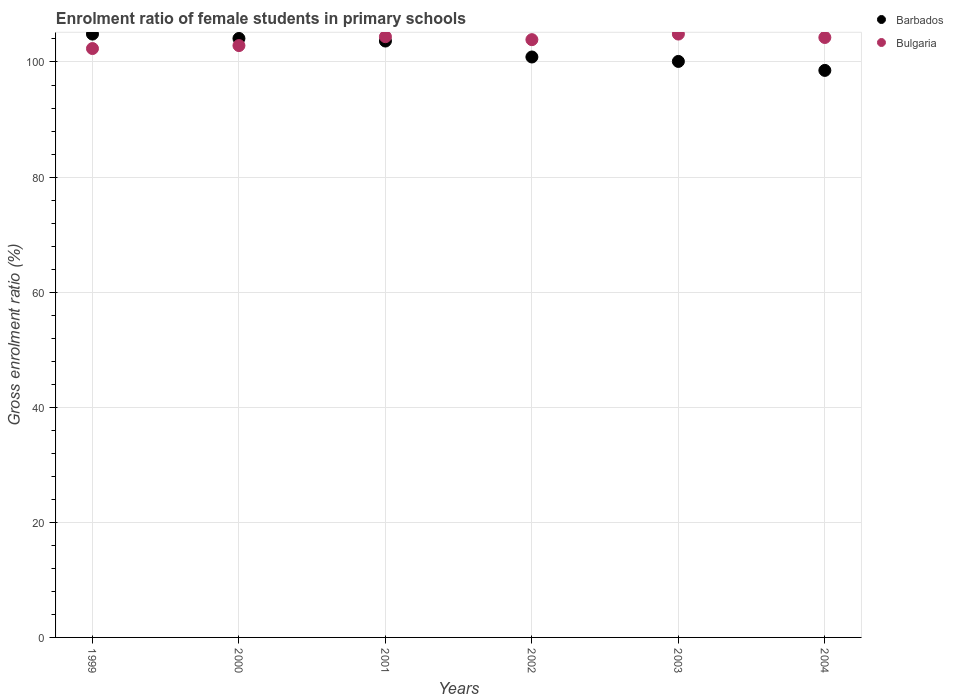How many different coloured dotlines are there?
Provide a short and direct response. 2. What is the enrolment ratio of female students in primary schools in Barbados in 2002?
Give a very brief answer. 100.87. Across all years, what is the maximum enrolment ratio of female students in primary schools in Bulgaria?
Make the answer very short. 104.85. Across all years, what is the minimum enrolment ratio of female students in primary schools in Barbados?
Offer a terse response. 98.54. In which year was the enrolment ratio of female students in primary schools in Bulgaria maximum?
Offer a very short reply. 2003. In which year was the enrolment ratio of female students in primary schools in Barbados minimum?
Provide a succinct answer. 2004. What is the total enrolment ratio of female students in primary schools in Bulgaria in the graph?
Make the answer very short. 622.57. What is the difference between the enrolment ratio of female students in primary schools in Barbados in 1999 and that in 2002?
Your answer should be compact. 3.98. What is the difference between the enrolment ratio of female students in primary schools in Bulgaria in 2004 and the enrolment ratio of female students in primary schools in Barbados in 2002?
Offer a terse response. 3.39. What is the average enrolment ratio of female students in primary schools in Barbados per year?
Give a very brief answer. 102.01. In the year 2001, what is the difference between the enrolment ratio of female students in primary schools in Bulgaria and enrolment ratio of female students in primary schools in Barbados?
Make the answer very short. 0.75. What is the ratio of the enrolment ratio of female students in primary schools in Bulgaria in 2002 to that in 2003?
Give a very brief answer. 0.99. Is the difference between the enrolment ratio of female students in primary schools in Bulgaria in 2001 and 2003 greater than the difference between the enrolment ratio of female students in primary schools in Barbados in 2001 and 2003?
Ensure brevity in your answer.  No. What is the difference between the highest and the second highest enrolment ratio of female students in primary schools in Barbados?
Give a very brief answer. 0.76. What is the difference between the highest and the lowest enrolment ratio of female students in primary schools in Barbados?
Provide a short and direct response. 6.31. Is the enrolment ratio of female students in primary schools in Barbados strictly less than the enrolment ratio of female students in primary schools in Bulgaria over the years?
Your answer should be very brief. No. How many dotlines are there?
Give a very brief answer. 2. What is the difference between two consecutive major ticks on the Y-axis?
Provide a short and direct response. 20. Are the values on the major ticks of Y-axis written in scientific E-notation?
Offer a terse response. No. Does the graph contain any zero values?
Make the answer very short. No. Does the graph contain grids?
Give a very brief answer. Yes. Where does the legend appear in the graph?
Provide a succinct answer. Top right. What is the title of the graph?
Offer a very short reply. Enrolment ratio of female students in primary schools. What is the label or title of the X-axis?
Keep it short and to the point. Years. What is the Gross enrolment ratio (%) of Barbados in 1999?
Your response must be concise. 104.85. What is the Gross enrolment ratio (%) in Bulgaria in 1999?
Your answer should be very brief. 102.34. What is the Gross enrolment ratio (%) of Barbados in 2000?
Make the answer very short. 104.09. What is the Gross enrolment ratio (%) of Bulgaria in 2000?
Give a very brief answer. 102.85. What is the Gross enrolment ratio (%) in Barbados in 2001?
Give a very brief answer. 103.64. What is the Gross enrolment ratio (%) in Bulgaria in 2001?
Ensure brevity in your answer.  104.39. What is the Gross enrolment ratio (%) in Barbados in 2002?
Ensure brevity in your answer.  100.87. What is the Gross enrolment ratio (%) of Bulgaria in 2002?
Your answer should be very brief. 103.88. What is the Gross enrolment ratio (%) of Barbados in 2003?
Your response must be concise. 100.1. What is the Gross enrolment ratio (%) in Bulgaria in 2003?
Give a very brief answer. 104.85. What is the Gross enrolment ratio (%) in Barbados in 2004?
Offer a terse response. 98.54. What is the Gross enrolment ratio (%) of Bulgaria in 2004?
Offer a terse response. 104.26. Across all years, what is the maximum Gross enrolment ratio (%) of Barbados?
Ensure brevity in your answer.  104.85. Across all years, what is the maximum Gross enrolment ratio (%) in Bulgaria?
Your answer should be compact. 104.85. Across all years, what is the minimum Gross enrolment ratio (%) in Barbados?
Offer a terse response. 98.54. Across all years, what is the minimum Gross enrolment ratio (%) of Bulgaria?
Give a very brief answer. 102.34. What is the total Gross enrolment ratio (%) of Barbados in the graph?
Provide a short and direct response. 612.08. What is the total Gross enrolment ratio (%) of Bulgaria in the graph?
Make the answer very short. 622.57. What is the difference between the Gross enrolment ratio (%) in Barbados in 1999 and that in 2000?
Your answer should be very brief. 0.76. What is the difference between the Gross enrolment ratio (%) in Bulgaria in 1999 and that in 2000?
Offer a terse response. -0.52. What is the difference between the Gross enrolment ratio (%) in Barbados in 1999 and that in 2001?
Keep it short and to the point. 1.21. What is the difference between the Gross enrolment ratio (%) of Bulgaria in 1999 and that in 2001?
Provide a short and direct response. -2.06. What is the difference between the Gross enrolment ratio (%) of Barbados in 1999 and that in 2002?
Your answer should be compact. 3.98. What is the difference between the Gross enrolment ratio (%) in Bulgaria in 1999 and that in 2002?
Keep it short and to the point. -1.54. What is the difference between the Gross enrolment ratio (%) in Barbados in 1999 and that in 2003?
Provide a succinct answer. 4.75. What is the difference between the Gross enrolment ratio (%) in Bulgaria in 1999 and that in 2003?
Make the answer very short. -2.52. What is the difference between the Gross enrolment ratio (%) in Barbados in 1999 and that in 2004?
Make the answer very short. 6.31. What is the difference between the Gross enrolment ratio (%) of Bulgaria in 1999 and that in 2004?
Offer a terse response. -1.92. What is the difference between the Gross enrolment ratio (%) of Barbados in 2000 and that in 2001?
Ensure brevity in your answer.  0.45. What is the difference between the Gross enrolment ratio (%) of Bulgaria in 2000 and that in 2001?
Give a very brief answer. -1.54. What is the difference between the Gross enrolment ratio (%) of Barbados in 2000 and that in 2002?
Offer a very short reply. 3.22. What is the difference between the Gross enrolment ratio (%) in Bulgaria in 2000 and that in 2002?
Your response must be concise. -1.03. What is the difference between the Gross enrolment ratio (%) of Barbados in 2000 and that in 2003?
Your response must be concise. 3.99. What is the difference between the Gross enrolment ratio (%) in Bulgaria in 2000 and that in 2003?
Your answer should be compact. -2. What is the difference between the Gross enrolment ratio (%) of Barbados in 2000 and that in 2004?
Your answer should be very brief. 5.55. What is the difference between the Gross enrolment ratio (%) in Bulgaria in 2000 and that in 2004?
Ensure brevity in your answer.  -1.4. What is the difference between the Gross enrolment ratio (%) of Barbados in 2001 and that in 2002?
Provide a succinct answer. 2.77. What is the difference between the Gross enrolment ratio (%) of Bulgaria in 2001 and that in 2002?
Provide a short and direct response. 0.52. What is the difference between the Gross enrolment ratio (%) of Barbados in 2001 and that in 2003?
Provide a succinct answer. 3.54. What is the difference between the Gross enrolment ratio (%) in Bulgaria in 2001 and that in 2003?
Your answer should be very brief. -0.46. What is the difference between the Gross enrolment ratio (%) in Barbados in 2001 and that in 2004?
Keep it short and to the point. 5.1. What is the difference between the Gross enrolment ratio (%) of Bulgaria in 2001 and that in 2004?
Ensure brevity in your answer.  0.14. What is the difference between the Gross enrolment ratio (%) in Barbados in 2002 and that in 2003?
Give a very brief answer. 0.77. What is the difference between the Gross enrolment ratio (%) of Bulgaria in 2002 and that in 2003?
Your answer should be very brief. -0.97. What is the difference between the Gross enrolment ratio (%) in Barbados in 2002 and that in 2004?
Your answer should be very brief. 2.33. What is the difference between the Gross enrolment ratio (%) of Bulgaria in 2002 and that in 2004?
Provide a succinct answer. -0.38. What is the difference between the Gross enrolment ratio (%) of Barbados in 2003 and that in 2004?
Offer a very short reply. 1.56. What is the difference between the Gross enrolment ratio (%) in Bulgaria in 2003 and that in 2004?
Provide a succinct answer. 0.6. What is the difference between the Gross enrolment ratio (%) in Barbados in 1999 and the Gross enrolment ratio (%) in Bulgaria in 2000?
Keep it short and to the point. 2. What is the difference between the Gross enrolment ratio (%) of Barbados in 1999 and the Gross enrolment ratio (%) of Bulgaria in 2001?
Your response must be concise. 0.45. What is the difference between the Gross enrolment ratio (%) in Barbados in 1999 and the Gross enrolment ratio (%) in Bulgaria in 2002?
Provide a short and direct response. 0.97. What is the difference between the Gross enrolment ratio (%) of Barbados in 1999 and the Gross enrolment ratio (%) of Bulgaria in 2003?
Make the answer very short. -0. What is the difference between the Gross enrolment ratio (%) in Barbados in 1999 and the Gross enrolment ratio (%) in Bulgaria in 2004?
Provide a succinct answer. 0.59. What is the difference between the Gross enrolment ratio (%) of Barbados in 2000 and the Gross enrolment ratio (%) of Bulgaria in 2001?
Keep it short and to the point. -0.31. What is the difference between the Gross enrolment ratio (%) of Barbados in 2000 and the Gross enrolment ratio (%) of Bulgaria in 2002?
Provide a short and direct response. 0.21. What is the difference between the Gross enrolment ratio (%) in Barbados in 2000 and the Gross enrolment ratio (%) in Bulgaria in 2003?
Offer a terse response. -0.76. What is the difference between the Gross enrolment ratio (%) in Barbados in 2000 and the Gross enrolment ratio (%) in Bulgaria in 2004?
Provide a short and direct response. -0.17. What is the difference between the Gross enrolment ratio (%) in Barbados in 2001 and the Gross enrolment ratio (%) in Bulgaria in 2002?
Make the answer very short. -0.24. What is the difference between the Gross enrolment ratio (%) of Barbados in 2001 and the Gross enrolment ratio (%) of Bulgaria in 2003?
Your answer should be compact. -1.21. What is the difference between the Gross enrolment ratio (%) of Barbados in 2001 and the Gross enrolment ratio (%) of Bulgaria in 2004?
Give a very brief answer. -0.62. What is the difference between the Gross enrolment ratio (%) of Barbados in 2002 and the Gross enrolment ratio (%) of Bulgaria in 2003?
Offer a very short reply. -3.98. What is the difference between the Gross enrolment ratio (%) in Barbados in 2002 and the Gross enrolment ratio (%) in Bulgaria in 2004?
Provide a short and direct response. -3.39. What is the difference between the Gross enrolment ratio (%) of Barbados in 2003 and the Gross enrolment ratio (%) of Bulgaria in 2004?
Offer a terse response. -4.16. What is the average Gross enrolment ratio (%) of Barbados per year?
Offer a very short reply. 102.01. What is the average Gross enrolment ratio (%) of Bulgaria per year?
Keep it short and to the point. 103.76. In the year 1999, what is the difference between the Gross enrolment ratio (%) in Barbados and Gross enrolment ratio (%) in Bulgaria?
Provide a succinct answer. 2.51. In the year 2000, what is the difference between the Gross enrolment ratio (%) of Barbados and Gross enrolment ratio (%) of Bulgaria?
Offer a very short reply. 1.24. In the year 2001, what is the difference between the Gross enrolment ratio (%) of Barbados and Gross enrolment ratio (%) of Bulgaria?
Your response must be concise. -0.75. In the year 2002, what is the difference between the Gross enrolment ratio (%) of Barbados and Gross enrolment ratio (%) of Bulgaria?
Your response must be concise. -3.01. In the year 2003, what is the difference between the Gross enrolment ratio (%) of Barbados and Gross enrolment ratio (%) of Bulgaria?
Provide a succinct answer. -4.75. In the year 2004, what is the difference between the Gross enrolment ratio (%) of Barbados and Gross enrolment ratio (%) of Bulgaria?
Ensure brevity in your answer.  -5.72. What is the ratio of the Gross enrolment ratio (%) in Barbados in 1999 to that in 2000?
Offer a terse response. 1.01. What is the ratio of the Gross enrolment ratio (%) of Bulgaria in 1999 to that in 2000?
Give a very brief answer. 0.99. What is the ratio of the Gross enrolment ratio (%) of Barbados in 1999 to that in 2001?
Offer a terse response. 1.01. What is the ratio of the Gross enrolment ratio (%) of Bulgaria in 1999 to that in 2001?
Your response must be concise. 0.98. What is the ratio of the Gross enrolment ratio (%) in Barbados in 1999 to that in 2002?
Give a very brief answer. 1.04. What is the ratio of the Gross enrolment ratio (%) in Bulgaria in 1999 to that in 2002?
Your response must be concise. 0.99. What is the ratio of the Gross enrolment ratio (%) in Barbados in 1999 to that in 2003?
Your response must be concise. 1.05. What is the ratio of the Gross enrolment ratio (%) of Barbados in 1999 to that in 2004?
Your response must be concise. 1.06. What is the ratio of the Gross enrolment ratio (%) in Bulgaria in 1999 to that in 2004?
Offer a very short reply. 0.98. What is the ratio of the Gross enrolment ratio (%) in Barbados in 2000 to that in 2001?
Keep it short and to the point. 1. What is the ratio of the Gross enrolment ratio (%) of Bulgaria in 2000 to that in 2001?
Make the answer very short. 0.99. What is the ratio of the Gross enrolment ratio (%) in Barbados in 2000 to that in 2002?
Give a very brief answer. 1.03. What is the ratio of the Gross enrolment ratio (%) in Bulgaria in 2000 to that in 2002?
Offer a terse response. 0.99. What is the ratio of the Gross enrolment ratio (%) in Barbados in 2000 to that in 2003?
Your answer should be very brief. 1.04. What is the ratio of the Gross enrolment ratio (%) of Bulgaria in 2000 to that in 2003?
Your answer should be compact. 0.98. What is the ratio of the Gross enrolment ratio (%) in Barbados in 2000 to that in 2004?
Give a very brief answer. 1.06. What is the ratio of the Gross enrolment ratio (%) of Bulgaria in 2000 to that in 2004?
Your answer should be compact. 0.99. What is the ratio of the Gross enrolment ratio (%) of Barbados in 2001 to that in 2002?
Offer a very short reply. 1.03. What is the ratio of the Gross enrolment ratio (%) in Barbados in 2001 to that in 2003?
Make the answer very short. 1.04. What is the ratio of the Gross enrolment ratio (%) of Bulgaria in 2001 to that in 2003?
Provide a succinct answer. 1. What is the ratio of the Gross enrolment ratio (%) of Barbados in 2001 to that in 2004?
Offer a terse response. 1.05. What is the ratio of the Gross enrolment ratio (%) of Bulgaria in 2001 to that in 2004?
Provide a succinct answer. 1. What is the ratio of the Gross enrolment ratio (%) in Barbados in 2002 to that in 2003?
Ensure brevity in your answer.  1.01. What is the ratio of the Gross enrolment ratio (%) of Bulgaria in 2002 to that in 2003?
Ensure brevity in your answer.  0.99. What is the ratio of the Gross enrolment ratio (%) in Barbados in 2002 to that in 2004?
Your answer should be compact. 1.02. What is the ratio of the Gross enrolment ratio (%) in Bulgaria in 2002 to that in 2004?
Make the answer very short. 1. What is the ratio of the Gross enrolment ratio (%) in Barbados in 2003 to that in 2004?
Provide a short and direct response. 1.02. What is the ratio of the Gross enrolment ratio (%) of Bulgaria in 2003 to that in 2004?
Provide a short and direct response. 1.01. What is the difference between the highest and the second highest Gross enrolment ratio (%) in Barbados?
Offer a very short reply. 0.76. What is the difference between the highest and the second highest Gross enrolment ratio (%) of Bulgaria?
Ensure brevity in your answer.  0.46. What is the difference between the highest and the lowest Gross enrolment ratio (%) of Barbados?
Make the answer very short. 6.31. What is the difference between the highest and the lowest Gross enrolment ratio (%) of Bulgaria?
Provide a succinct answer. 2.52. 